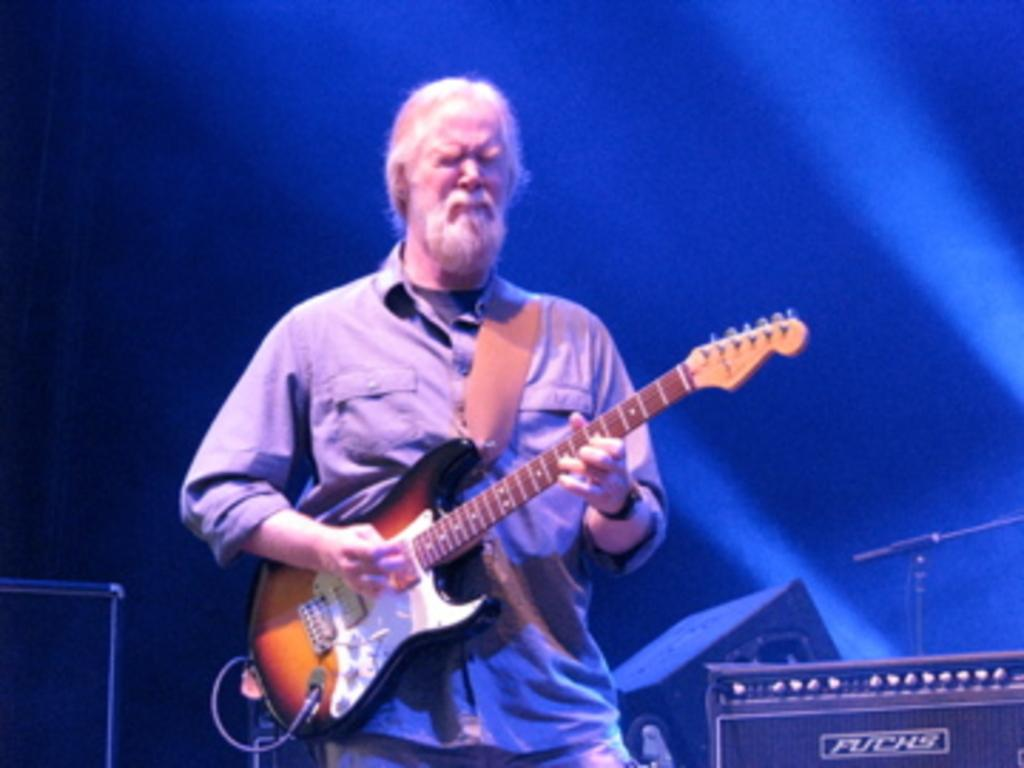What is the main subject of the image? The main subject of the image is a man. What is the man holding in the image? The man is holding a guitar. What type of creature is the man interacting with while holding the guitar in the image? There is no creature present in the image; the man is simply holding a guitar. What type of laborer is the man in the image? The provided facts do not indicate that the man is a laborer, nor is there any information about his occupation. 